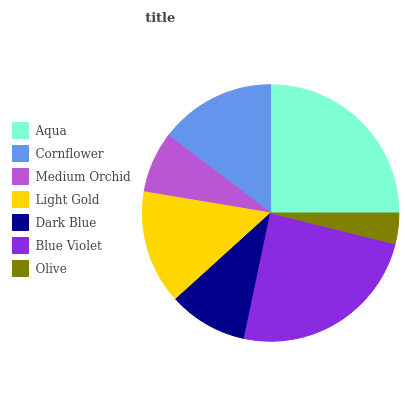Is Olive the minimum?
Answer yes or no. Yes. Is Aqua the maximum?
Answer yes or no. Yes. Is Cornflower the minimum?
Answer yes or no. No. Is Cornflower the maximum?
Answer yes or no. No. Is Aqua greater than Cornflower?
Answer yes or no. Yes. Is Cornflower less than Aqua?
Answer yes or no. Yes. Is Cornflower greater than Aqua?
Answer yes or no. No. Is Aqua less than Cornflower?
Answer yes or no. No. Is Light Gold the high median?
Answer yes or no. Yes. Is Light Gold the low median?
Answer yes or no. Yes. Is Medium Orchid the high median?
Answer yes or no. No. Is Olive the low median?
Answer yes or no. No. 